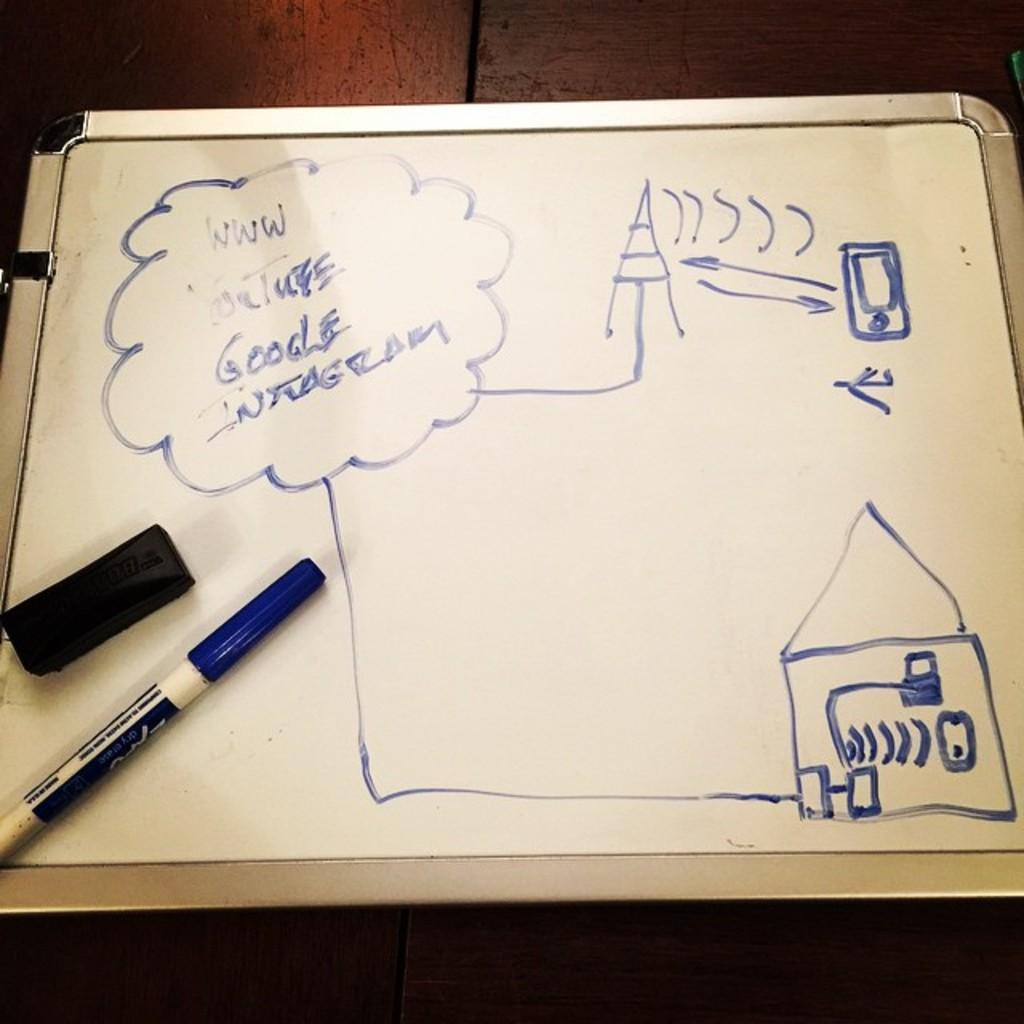<image>
Relay a brief, clear account of the picture shown. Whiteboard thhat shows an antenna and the word "Google" on there. 